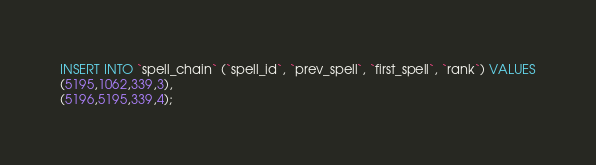Convert code to text. <code><loc_0><loc_0><loc_500><loc_500><_SQL_>INSERT INTO `spell_chain` (`spell_id`, `prev_spell`, `first_spell`, `rank`) VALUES
(5195,1062,339,3),
(5196,5195,339,4);
</code> 